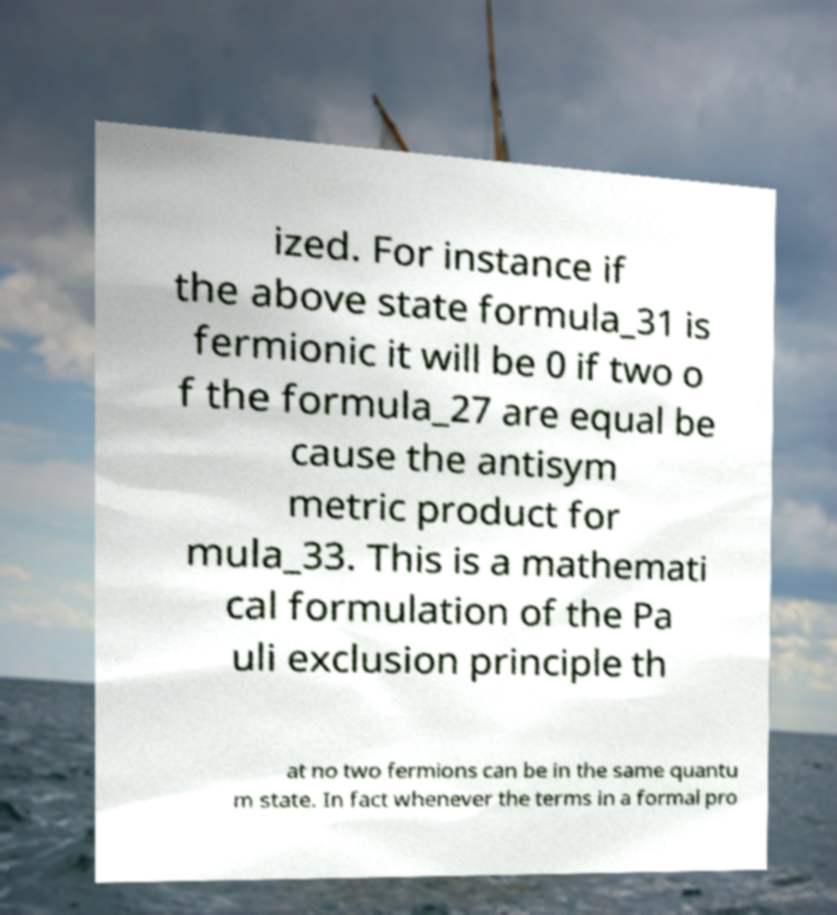Can you read and provide the text displayed in the image?This photo seems to have some interesting text. Can you extract and type it out for me? ized. For instance if the above state formula_31 is fermionic it will be 0 if two o f the formula_27 are equal be cause the antisym metric product for mula_33. This is a mathemati cal formulation of the Pa uli exclusion principle th at no two fermions can be in the same quantu m state. In fact whenever the terms in a formal pro 